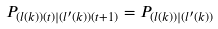Convert formula to latex. <formula><loc_0><loc_0><loc_500><loc_500>P _ { ( l ( k ) ) ( t ) | ( l ^ { \prime } ( k ) ) ( t + 1 ) } = P _ { ( l ( k ) ) | ( l ^ { \prime } ( k ) ) }</formula> 